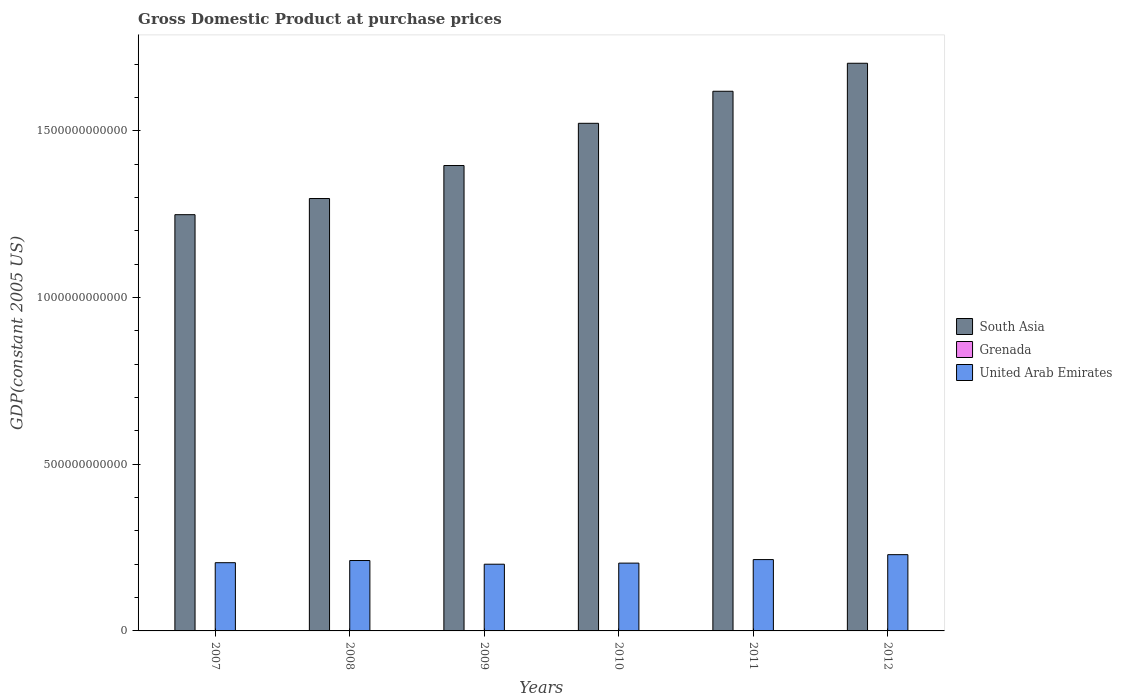How many different coloured bars are there?
Provide a succinct answer. 3. How many groups of bars are there?
Provide a short and direct response. 6. Are the number of bars per tick equal to the number of legend labels?
Keep it short and to the point. Yes. Are the number of bars on each tick of the X-axis equal?
Provide a short and direct response. Yes. How many bars are there on the 2nd tick from the left?
Keep it short and to the point. 3. How many bars are there on the 5th tick from the right?
Give a very brief answer. 3. What is the GDP at purchase prices in South Asia in 2007?
Keep it short and to the point. 1.25e+12. Across all years, what is the maximum GDP at purchase prices in South Asia?
Offer a terse response. 1.70e+12. Across all years, what is the minimum GDP at purchase prices in Grenada?
Make the answer very short. 6.62e+08. What is the total GDP at purchase prices in United Arab Emirates in the graph?
Your answer should be very brief. 1.26e+12. What is the difference between the GDP at purchase prices in Grenada in 2007 and that in 2012?
Your response must be concise. 4.66e+07. What is the difference between the GDP at purchase prices in South Asia in 2007 and the GDP at purchase prices in Grenada in 2010?
Offer a very short reply. 1.25e+12. What is the average GDP at purchase prices in South Asia per year?
Offer a very short reply. 1.46e+12. In the year 2010, what is the difference between the GDP at purchase prices in United Arab Emirates and GDP at purchase prices in South Asia?
Offer a terse response. -1.32e+12. What is the ratio of the GDP at purchase prices in Grenada in 2010 to that in 2012?
Keep it short and to the point. 1. What is the difference between the highest and the second highest GDP at purchase prices in South Asia?
Provide a short and direct response. 8.40e+1. What is the difference between the highest and the lowest GDP at purchase prices in South Asia?
Your answer should be compact. 4.54e+11. In how many years, is the GDP at purchase prices in United Arab Emirates greater than the average GDP at purchase prices in United Arab Emirates taken over all years?
Provide a short and direct response. 3. What does the 2nd bar from the left in 2010 represents?
Your answer should be compact. Grenada. How many bars are there?
Offer a terse response. 18. Are all the bars in the graph horizontal?
Your answer should be very brief. No. How many years are there in the graph?
Your answer should be very brief. 6. What is the difference between two consecutive major ticks on the Y-axis?
Your answer should be very brief. 5.00e+11. Are the values on the major ticks of Y-axis written in scientific E-notation?
Make the answer very short. No. How many legend labels are there?
Ensure brevity in your answer.  3. What is the title of the graph?
Provide a short and direct response. Gross Domestic Product at purchase prices. Does "Vietnam" appear as one of the legend labels in the graph?
Keep it short and to the point. No. What is the label or title of the X-axis?
Ensure brevity in your answer.  Years. What is the label or title of the Y-axis?
Keep it short and to the point. GDP(constant 2005 US). What is the GDP(constant 2005 US) in South Asia in 2007?
Provide a short and direct response. 1.25e+12. What is the GDP(constant 2005 US) in Grenada in 2007?
Your answer should be very brief. 7.08e+08. What is the GDP(constant 2005 US) of United Arab Emirates in 2007?
Provide a succinct answer. 2.05e+11. What is the GDP(constant 2005 US) in South Asia in 2008?
Offer a terse response. 1.30e+12. What is the GDP(constant 2005 US) in Grenada in 2008?
Give a very brief answer. 7.15e+08. What is the GDP(constant 2005 US) of United Arab Emirates in 2008?
Your response must be concise. 2.11e+11. What is the GDP(constant 2005 US) of South Asia in 2009?
Your answer should be very brief. 1.40e+12. What is the GDP(constant 2005 US) of Grenada in 2009?
Offer a terse response. 6.68e+08. What is the GDP(constant 2005 US) in United Arab Emirates in 2009?
Your response must be concise. 2.00e+11. What is the GDP(constant 2005 US) of South Asia in 2010?
Provide a short and direct response. 1.52e+12. What is the GDP(constant 2005 US) in Grenada in 2010?
Your answer should be compact. 6.64e+08. What is the GDP(constant 2005 US) in United Arab Emirates in 2010?
Your response must be concise. 2.03e+11. What is the GDP(constant 2005 US) in South Asia in 2011?
Your answer should be very brief. 1.62e+12. What is the GDP(constant 2005 US) of Grenada in 2011?
Your answer should be compact. 6.70e+08. What is the GDP(constant 2005 US) of United Arab Emirates in 2011?
Give a very brief answer. 2.14e+11. What is the GDP(constant 2005 US) of South Asia in 2012?
Keep it short and to the point. 1.70e+12. What is the GDP(constant 2005 US) of Grenada in 2012?
Provide a succinct answer. 6.62e+08. What is the GDP(constant 2005 US) of United Arab Emirates in 2012?
Offer a terse response. 2.29e+11. Across all years, what is the maximum GDP(constant 2005 US) of South Asia?
Offer a terse response. 1.70e+12. Across all years, what is the maximum GDP(constant 2005 US) of Grenada?
Your answer should be very brief. 7.15e+08. Across all years, what is the maximum GDP(constant 2005 US) in United Arab Emirates?
Offer a terse response. 2.29e+11. Across all years, what is the minimum GDP(constant 2005 US) in South Asia?
Keep it short and to the point. 1.25e+12. Across all years, what is the minimum GDP(constant 2005 US) in Grenada?
Your response must be concise. 6.62e+08. Across all years, what is the minimum GDP(constant 2005 US) of United Arab Emirates?
Your response must be concise. 2.00e+11. What is the total GDP(constant 2005 US) of South Asia in the graph?
Provide a succinct answer. 8.79e+12. What is the total GDP(constant 2005 US) of Grenada in the graph?
Provide a succinct answer. 4.09e+09. What is the total GDP(constant 2005 US) in United Arab Emirates in the graph?
Provide a succinct answer. 1.26e+12. What is the difference between the GDP(constant 2005 US) of South Asia in 2007 and that in 2008?
Keep it short and to the point. -4.85e+1. What is the difference between the GDP(constant 2005 US) in Grenada in 2007 and that in 2008?
Your response must be concise. -6.72e+06. What is the difference between the GDP(constant 2005 US) of United Arab Emirates in 2007 and that in 2008?
Your answer should be compact. -6.53e+09. What is the difference between the GDP(constant 2005 US) in South Asia in 2007 and that in 2009?
Offer a terse response. -1.48e+11. What is the difference between the GDP(constant 2005 US) in Grenada in 2007 and that in 2009?
Provide a short and direct response. 4.06e+07. What is the difference between the GDP(constant 2005 US) of United Arab Emirates in 2007 and that in 2009?
Offer a very short reply. 4.54e+09. What is the difference between the GDP(constant 2005 US) of South Asia in 2007 and that in 2010?
Ensure brevity in your answer.  -2.74e+11. What is the difference between the GDP(constant 2005 US) in Grenada in 2007 and that in 2010?
Offer a terse response. 4.40e+07. What is the difference between the GDP(constant 2005 US) of United Arab Emirates in 2007 and that in 2010?
Offer a terse response. 1.27e+09. What is the difference between the GDP(constant 2005 US) in South Asia in 2007 and that in 2011?
Your answer should be compact. -3.70e+11. What is the difference between the GDP(constant 2005 US) in Grenada in 2007 and that in 2011?
Provide a short and direct response. 3.89e+07. What is the difference between the GDP(constant 2005 US) of United Arab Emirates in 2007 and that in 2011?
Provide a short and direct response. -9.33e+09. What is the difference between the GDP(constant 2005 US) of South Asia in 2007 and that in 2012?
Give a very brief answer. -4.54e+11. What is the difference between the GDP(constant 2005 US) in Grenada in 2007 and that in 2012?
Your answer should be compact. 4.66e+07. What is the difference between the GDP(constant 2005 US) of United Arab Emirates in 2007 and that in 2012?
Your answer should be compact. -2.41e+1. What is the difference between the GDP(constant 2005 US) of South Asia in 2008 and that in 2009?
Provide a succinct answer. -9.90e+1. What is the difference between the GDP(constant 2005 US) in Grenada in 2008 and that in 2009?
Your answer should be very brief. 4.73e+07. What is the difference between the GDP(constant 2005 US) in United Arab Emirates in 2008 and that in 2009?
Keep it short and to the point. 1.11e+1. What is the difference between the GDP(constant 2005 US) of South Asia in 2008 and that in 2010?
Your answer should be very brief. -2.26e+11. What is the difference between the GDP(constant 2005 US) of Grenada in 2008 and that in 2010?
Provide a short and direct response. 5.07e+07. What is the difference between the GDP(constant 2005 US) in United Arab Emirates in 2008 and that in 2010?
Give a very brief answer. 7.80e+09. What is the difference between the GDP(constant 2005 US) of South Asia in 2008 and that in 2011?
Ensure brevity in your answer.  -3.22e+11. What is the difference between the GDP(constant 2005 US) in Grenada in 2008 and that in 2011?
Ensure brevity in your answer.  4.56e+07. What is the difference between the GDP(constant 2005 US) of United Arab Emirates in 2008 and that in 2011?
Provide a short and direct response. -2.79e+09. What is the difference between the GDP(constant 2005 US) in South Asia in 2008 and that in 2012?
Make the answer very short. -4.06e+11. What is the difference between the GDP(constant 2005 US) in Grenada in 2008 and that in 2012?
Ensure brevity in your answer.  5.34e+07. What is the difference between the GDP(constant 2005 US) of United Arab Emirates in 2008 and that in 2012?
Offer a very short reply. -1.75e+1. What is the difference between the GDP(constant 2005 US) in South Asia in 2009 and that in 2010?
Give a very brief answer. -1.27e+11. What is the difference between the GDP(constant 2005 US) of Grenada in 2009 and that in 2010?
Provide a short and direct response. 3.41e+06. What is the difference between the GDP(constant 2005 US) of United Arab Emirates in 2009 and that in 2010?
Provide a short and direct response. -3.27e+09. What is the difference between the GDP(constant 2005 US) of South Asia in 2009 and that in 2011?
Your answer should be very brief. -2.23e+11. What is the difference between the GDP(constant 2005 US) in Grenada in 2009 and that in 2011?
Provide a succinct answer. -1.67e+06. What is the difference between the GDP(constant 2005 US) of United Arab Emirates in 2009 and that in 2011?
Your answer should be very brief. -1.39e+1. What is the difference between the GDP(constant 2005 US) in South Asia in 2009 and that in 2012?
Provide a short and direct response. -3.07e+11. What is the difference between the GDP(constant 2005 US) in Grenada in 2009 and that in 2012?
Provide a short and direct response. 6.07e+06. What is the difference between the GDP(constant 2005 US) of United Arab Emirates in 2009 and that in 2012?
Ensure brevity in your answer.  -2.86e+1. What is the difference between the GDP(constant 2005 US) of South Asia in 2010 and that in 2011?
Your answer should be very brief. -9.62e+1. What is the difference between the GDP(constant 2005 US) of Grenada in 2010 and that in 2011?
Your answer should be very brief. -5.08e+06. What is the difference between the GDP(constant 2005 US) in United Arab Emirates in 2010 and that in 2011?
Provide a succinct answer. -1.06e+1. What is the difference between the GDP(constant 2005 US) in South Asia in 2010 and that in 2012?
Provide a short and direct response. -1.80e+11. What is the difference between the GDP(constant 2005 US) of Grenada in 2010 and that in 2012?
Keep it short and to the point. 2.65e+06. What is the difference between the GDP(constant 2005 US) of United Arab Emirates in 2010 and that in 2012?
Your response must be concise. -2.53e+1. What is the difference between the GDP(constant 2005 US) of South Asia in 2011 and that in 2012?
Provide a succinct answer. -8.40e+1. What is the difference between the GDP(constant 2005 US) of Grenada in 2011 and that in 2012?
Offer a terse response. 7.74e+06. What is the difference between the GDP(constant 2005 US) in United Arab Emirates in 2011 and that in 2012?
Provide a succinct answer. -1.48e+1. What is the difference between the GDP(constant 2005 US) in South Asia in 2007 and the GDP(constant 2005 US) in Grenada in 2008?
Offer a very short reply. 1.25e+12. What is the difference between the GDP(constant 2005 US) of South Asia in 2007 and the GDP(constant 2005 US) of United Arab Emirates in 2008?
Ensure brevity in your answer.  1.04e+12. What is the difference between the GDP(constant 2005 US) of Grenada in 2007 and the GDP(constant 2005 US) of United Arab Emirates in 2008?
Keep it short and to the point. -2.11e+11. What is the difference between the GDP(constant 2005 US) in South Asia in 2007 and the GDP(constant 2005 US) in Grenada in 2009?
Make the answer very short. 1.25e+12. What is the difference between the GDP(constant 2005 US) of South Asia in 2007 and the GDP(constant 2005 US) of United Arab Emirates in 2009?
Offer a very short reply. 1.05e+12. What is the difference between the GDP(constant 2005 US) in Grenada in 2007 and the GDP(constant 2005 US) in United Arab Emirates in 2009?
Provide a short and direct response. -1.99e+11. What is the difference between the GDP(constant 2005 US) of South Asia in 2007 and the GDP(constant 2005 US) of Grenada in 2010?
Your response must be concise. 1.25e+12. What is the difference between the GDP(constant 2005 US) in South Asia in 2007 and the GDP(constant 2005 US) in United Arab Emirates in 2010?
Give a very brief answer. 1.05e+12. What is the difference between the GDP(constant 2005 US) in Grenada in 2007 and the GDP(constant 2005 US) in United Arab Emirates in 2010?
Provide a succinct answer. -2.03e+11. What is the difference between the GDP(constant 2005 US) in South Asia in 2007 and the GDP(constant 2005 US) in Grenada in 2011?
Your answer should be compact. 1.25e+12. What is the difference between the GDP(constant 2005 US) in South Asia in 2007 and the GDP(constant 2005 US) in United Arab Emirates in 2011?
Offer a terse response. 1.03e+12. What is the difference between the GDP(constant 2005 US) of Grenada in 2007 and the GDP(constant 2005 US) of United Arab Emirates in 2011?
Provide a succinct answer. -2.13e+11. What is the difference between the GDP(constant 2005 US) in South Asia in 2007 and the GDP(constant 2005 US) in Grenada in 2012?
Your answer should be very brief. 1.25e+12. What is the difference between the GDP(constant 2005 US) in South Asia in 2007 and the GDP(constant 2005 US) in United Arab Emirates in 2012?
Offer a very short reply. 1.02e+12. What is the difference between the GDP(constant 2005 US) in Grenada in 2007 and the GDP(constant 2005 US) in United Arab Emirates in 2012?
Offer a very short reply. -2.28e+11. What is the difference between the GDP(constant 2005 US) of South Asia in 2008 and the GDP(constant 2005 US) of Grenada in 2009?
Your answer should be compact. 1.30e+12. What is the difference between the GDP(constant 2005 US) of South Asia in 2008 and the GDP(constant 2005 US) of United Arab Emirates in 2009?
Provide a succinct answer. 1.10e+12. What is the difference between the GDP(constant 2005 US) of Grenada in 2008 and the GDP(constant 2005 US) of United Arab Emirates in 2009?
Your answer should be very brief. -1.99e+11. What is the difference between the GDP(constant 2005 US) of South Asia in 2008 and the GDP(constant 2005 US) of Grenada in 2010?
Keep it short and to the point. 1.30e+12. What is the difference between the GDP(constant 2005 US) in South Asia in 2008 and the GDP(constant 2005 US) in United Arab Emirates in 2010?
Give a very brief answer. 1.09e+12. What is the difference between the GDP(constant 2005 US) of Grenada in 2008 and the GDP(constant 2005 US) of United Arab Emirates in 2010?
Make the answer very short. -2.03e+11. What is the difference between the GDP(constant 2005 US) of South Asia in 2008 and the GDP(constant 2005 US) of Grenada in 2011?
Provide a succinct answer. 1.30e+12. What is the difference between the GDP(constant 2005 US) of South Asia in 2008 and the GDP(constant 2005 US) of United Arab Emirates in 2011?
Offer a terse response. 1.08e+12. What is the difference between the GDP(constant 2005 US) in Grenada in 2008 and the GDP(constant 2005 US) in United Arab Emirates in 2011?
Provide a succinct answer. -2.13e+11. What is the difference between the GDP(constant 2005 US) in South Asia in 2008 and the GDP(constant 2005 US) in Grenada in 2012?
Keep it short and to the point. 1.30e+12. What is the difference between the GDP(constant 2005 US) in South Asia in 2008 and the GDP(constant 2005 US) in United Arab Emirates in 2012?
Ensure brevity in your answer.  1.07e+12. What is the difference between the GDP(constant 2005 US) of Grenada in 2008 and the GDP(constant 2005 US) of United Arab Emirates in 2012?
Ensure brevity in your answer.  -2.28e+11. What is the difference between the GDP(constant 2005 US) in South Asia in 2009 and the GDP(constant 2005 US) in Grenada in 2010?
Your answer should be very brief. 1.40e+12. What is the difference between the GDP(constant 2005 US) of South Asia in 2009 and the GDP(constant 2005 US) of United Arab Emirates in 2010?
Give a very brief answer. 1.19e+12. What is the difference between the GDP(constant 2005 US) of Grenada in 2009 and the GDP(constant 2005 US) of United Arab Emirates in 2010?
Provide a short and direct response. -2.03e+11. What is the difference between the GDP(constant 2005 US) in South Asia in 2009 and the GDP(constant 2005 US) in Grenada in 2011?
Offer a terse response. 1.40e+12. What is the difference between the GDP(constant 2005 US) in South Asia in 2009 and the GDP(constant 2005 US) in United Arab Emirates in 2011?
Your answer should be very brief. 1.18e+12. What is the difference between the GDP(constant 2005 US) of Grenada in 2009 and the GDP(constant 2005 US) of United Arab Emirates in 2011?
Make the answer very short. -2.13e+11. What is the difference between the GDP(constant 2005 US) in South Asia in 2009 and the GDP(constant 2005 US) in Grenada in 2012?
Your answer should be very brief. 1.40e+12. What is the difference between the GDP(constant 2005 US) in South Asia in 2009 and the GDP(constant 2005 US) in United Arab Emirates in 2012?
Your answer should be very brief. 1.17e+12. What is the difference between the GDP(constant 2005 US) of Grenada in 2009 and the GDP(constant 2005 US) of United Arab Emirates in 2012?
Keep it short and to the point. -2.28e+11. What is the difference between the GDP(constant 2005 US) of South Asia in 2010 and the GDP(constant 2005 US) of Grenada in 2011?
Make the answer very short. 1.52e+12. What is the difference between the GDP(constant 2005 US) of South Asia in 2010 and the GDP(constant 2005 US) of United Arab Emirates in 2011?
Your response must be concise. 1.31e+12. What is the difference between the GDP(constant 2005 US) in Grenada in 2010 and the GDP(constant 2005 US) in United Arab Emirates in 2011?
Your answer should be very brief. -2.13e+11. What is the difference between the GDP(constant 2005 US) of South Asia in 2010 and the GDP(constant 2005 US) of Grenada in 2012?
Give a very brief answer. 1.52e+12. What is the difference between the GDP(constant 2005 US) in South Asia in 2010 and the GDP(constant 2005 US) in United Arab Emirates in 2012?
Offer a very short reply. 1.29e+12. What is the difference between the GDP(constant 2005 US) in Grenada in 2010 and the GDP(constant 2005 US) in United Arab Emirates in 2012?
Provide a short and direct response. -2.28e+11. What is the difference between the GDP(constant 2005 US) in South Asia in 2011 and the GDP(constant 2005 US) in Grenada in 2012?
Make the answer very short. 1.62e+12. What is the difference between the GDP(constant 2005 US) in South Asia in 2011 and the GDP(constant 2005 US) in United Arab Emirates in 2012?
Your answer should be compact. 1.39e+12. What is the difference between the GDP(constant 2005 US) in Grenada in 2011 and the GDP(constant 2005 US) in United Arab Emirates in 2012?
Make the answer very short. -2.28e+11. What is the average GDP(constant 2005 US) in South Asia per year?
Provide a succinct answer. 1.46e+12. What is the average GDP(constant 2005 US) in Grenada per year?
Give a very brief answer. 6.81e+08. What is the average GDP(constant 2005 US) of United Arab Emirates per year?
Offer a very short reply. 2.10e+11. In the year 2007, what is the difference between the GDP(constant 2005 US) in South Asia and GDP(constant 2005 US) in Grenada?
Offer a very short reply. 1.25e+12. In the year 2007, what is the difference between the GDP(constant 2005 US) in South Asia and GDP(constant 2005 US) in United Arab Emirates?
Your response must be concise. 1.04e+12. In the year 2007, what is the difference between the GDP(constant 2005 US) of Grenada and GDP(constant 2005 US) of United Arab Emirates?
Provide a succinct answer. -2.04e+11. In the year 2008, what is the difference between the GDP(constant 2005 US) of South Asia and GDP(constant 2005 US) of Grenada?
Keep it short and to the point. 1.30e+12. In the year 2008, what is the difference between the GDP(constant 2005 US) of South Asia and GDP(constant 2005 US) of United Arab Emirates?
Keep it short and to the point. 1.09e+12. In the year 2008, what is the difference between the GDP(constant 2005 US) of Grenada and GDP(constant 2005 US) of United Arab Emirates?
Offer a very short reply. -2.11e+11. In the year 2009, what is the difference between the GDP(constant 2005 US) in South Asia and GDP(constant 2005 US) in Grenada?
Offer a very short reply. 1.40e+12. In the year 2009, what is the difference between the GDP(constant 2005 US) in South Asia and GDP(constant 2005 US) in United Arab Emirates?
Your answer should be compact. 1.20e+12. In the year 2009, what is the difference between the GDP(constant 2005 US) in Grenada and GDP(constant 2005 US) in United Arab Emirates?
Your response must be concise. -1.99e+11. In the year 2010, what is the difference between the GDP(constant 2005 US) of South Asia and GDP(constant 2005 US) of Grenada?
Your answer should be compact. 1.52e+12. In the year 2010, what is the difference between the GDP(constant 2005 US) of South Asia and GDP(constant 2005 US) of United Arab Emirates?
Make the answer very short. 1.32e+12. In the year 2010, what is the difference between the GDP(constant 2005 US) in Grenada and GDP(constant 2005 US) in United Arab Emirates?
Offer a terse response. -2.03e+11. In the year 2011, what is the difference between the GDP(constant 2005 US) of South Asia and GDP(constant 2005 US) of Grenada?
Provide a short and direct response. 1.62e+12. In the year 2011, what is the difference between the GDP(constant 2005 US) in South Asia and GDP(constant 2005 US) in United Arab Emirates?
Ensure brevity in your answer.  1.41e+12. In the year 2011, what is the difference between the GDP(constant 2005 US) of Grenada and GDP(constant 2005 US) of United Arab Emirates?
Ensure brevity in your answer.  -2.13e+11. In the year 2012, what is the difference between the GDP(constant 2005 US) of South Asia and GDP(constant 2005 US) of Grenada?
Provide a succinct answer. 1.70e+12. In the year 2012, what is the difference between the GDP(constant 2005 US) of South Asia and GDP(constant 2005 US) of United Arab Emirates?
Your answer should be very brief. 1.47e+12. In the year 2012, what is the difference between the GDP(constant 2005 US) in Grenada and GDP(constant 2005 US) in United Arab Emirates?
Offer a very short reply. -2.28e+11. What is the ratio of the GDP(constant 2005 US) in South Asia in 2007 to that in 2008?
Provide a succinct answer. 0.96. What is the ratio of the GDP(constant 2005 US) of Grenada in 2007 to that in 2008?
Keep it short and to the point. 0.99. What is the ratio of the GDP(constant 2005 US) in United Arab Emirates in 2007 to that in 2008?
Your response must be concise. 0.97. What is the ratio of the GDP(constant 2005 US) of South Asia in 2007 to that in 2009?
Your answer should be compact. 0.89. What is the ratio of the GDP(constant 2005 US) of Grenada in 2007 to that in 2009?
Provide a succinct answer. 1.06. What is the ratio of the GDP(constant 2005 US) in United Arab Emirates in 2007 to that in 2009?
Ensure brevity in your answer.  1.02. What is the ratio of the GDP(constant 2005 US) of South Asia in 2007 to that in 2010?
Your answer should be very brief. 0.82. What is the ratio of the GDP(constant 2005 US) in Grenada in 2007 to that in 2010?
Offer a very short reply. 1.07. What is the ratio of the GDP(constant 2005 US) of United Arab Emirates in 2007 to that in 2010?
Your answer should be very brief. 1.01. What is the ratio of the GDP(constant 2005 US) of South Asia in 2007 to that in 2011?
Give a very brief answer. 0.77. What is the ratio of the GDP(constant 2005 US) in Grenada in 2007 to that in 2011?
Provide a succinct answer. 1.06. What is the ratio of the GDP(constant 2005 US) in United Arab Emirates in 2007 to that in 2011?
Provide a succinct answer. 0.96. What is the ratio of the GDP(constant 2005 US) in South Asia in 2007 to that in 2012?
Give a very brief answer. 0.73. What is the ratio of the GDP(constant 2005 US) of Grenada in 2007 to that in 2012?
Your answer should be very brief. 1.07. What is the ratio of the GDP(constant 2005 US) of United Arab Emirates in 2007 to that in 2012?
Ensure brevity in your answer.  0.89. What is the ratio of the GDP(constant 2005 US) in South Asia in 2008 to that in 2009?
Provide a short and direct response. 0.93. What is the ratio of the GDP(constant 2005 US) of Grenada in 2008 to that in 2009?
Offer a terse response. 1.07. What is the ratio of the GDP(constant 2005 US) in United Arab Emirates in 2008 to that in 2009?
Give a very brief answer. 1.06. What is the ratio of the GDP(constant 2005 US) of South Asia in 2008 to that in 2010?
Your answer should be very brief. 0.85. What is the ratio of the GDP(constant 2005 US) in Grenada in 2008 to that in 2010?
Make the answer very short. 1.08. What is the ratio of the GDP(constant 2005 US) of United Arab Emirates in 2008 to that in 2010?
Give a very brief answer. 1.04. What is the ratio of the GDP(constant 2005 US) in South Asia in 2008 to that in 2011?
Provide a succinct answer. 0.8. What is the ratio of the GDP(constant 2005 US) in Grenada in 2008 to that in 2011?
Your answer should be compact. 1.07. What is the ratio of the GDP(constant 2005 US) in South Asia in 2008 to that in 2012?
Give a very brief answer. 0.76. What is the ratio of the GDP(constant 2005 US) of Grenada in 2008 to that in 2012?
Offer a terse response. 1.08. What is the ratio of the GDP(constant 2005 US) in United Arab Emirates in 2008 to that in 2012?
Offer a terse response. 0.92. What is the ratio of the GDP(constant 2005 US) of South Asia in 2009 to that in 2010?
Offer a terse response. 0.92. What is the ratio of the GDP(constant 2005 US) of Grenada in 2009 to that in 2010?
Make the answer very short. 1.01. What is the ratio of the GDP(constant 2005 US) in United Arab Emirates in 2009 to that in 2010?
Your answer should be very brief. 0.98. What is the ratio of the GDP(constant 2005 US) of South Asia in 2009 to that in 2011?
Your response must be concise. 0.86. What is the ratio of the GDP(constant 2005 US) of United Arab Emirates in 2009 to that in 2011?
Offer a terse response. 0.94. What is the ratio of the GDP(constant 2005 US) in South Asia in 2009 to that in 2012?
Offer a very short reply. 0.82. What is the ratio of the GDP(constant 2005 US) in Grenada in 2009 to that in 2012?
Your response must be concise. 1.01. What is the ratio of the GDP(constant 2005 US) in United Arab Emirates in 2009 to that in 2012?
Your answer should be compact. 0.87. What is the ratio of the GDP(constant 2005 US) in South Asia in 2010 to that in 2011?
Provide a succinct answer. 0.94. What is the ratio of the GDP(constant 2005 US) in United Arab Emirates in 2010 to that in 2011?
Give a very brief answer. 0.95. What is the ratio of the GDP(constant 2005 US) of South Asia in 2010 to that in 2012?
Provide a short and direct response. 0.89. What is the ratio of the GDP(constant 2005 US) in Grenada in 2010 to that in 2012?
Keep it short and to the point. 1. What is the ratio of the GDP(constant 2005 US) of United Arab Emirates in 2010 to that in 2012?
Your answer should be very brief. 0.89. What is the ratio of the GDP(constant 2005 US) in South Asia in 2011 to that in 2012?
Your response must be concise. 0.95. What is the ratio of the GDP(constant 2005 US) in Grenada in 2011 to that in 2012?
Your answer should be very brief. 1.01. What is the ratio of the GDP(constant 2005 US) of United Arab Emirates in 2011 to that in 2012?
Offer a terse response. 0.94. What is the difference between the highest and the second highest GDP(constant 2005 US) in South Asia?
Offer a very short reply. 8.40e+1. What is the difference between the highest and the second highest GDP(constant 2005 US) in Grenada?
Keep it short and to the point. 6.72e+06. What is the difference between the highest and the second highest GDP(constant 2005 US) in United Arab Emirates?
Keep it short and to the point. 1.48e+1. What is the difference between the highest and the lowest GDP(constant 2005 US) in South Asia?
Give a very brief answer. 4.54e+11. What is the difference between the highest and the lowest GDP(constant 2005 US) of Grenada?
Your response must be concise. 5.34e+07. What is the difference between the highest and the lowest GDP(constant 2005 US) of United Arab Emirates?
Your answer should be very brief. 2.86e+1. 